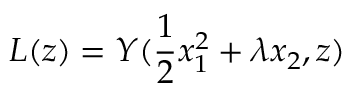<formula> <loc_0><loc_0><loc_500><loc_500>L ( z ) = Y ( \frac { 1 } { 2 } x _ { 1 } ^ { 2 } + \lambda x _ { 2 } , z )</formula> 